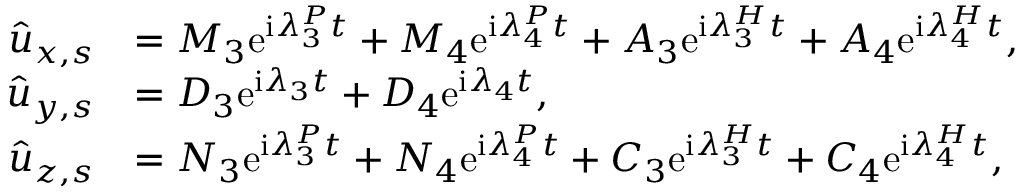<formula> <loc_0><loc_0><loc_500><loc_500>\begin{array} { r l } { \hat { u } _ { x , s } } & { = M _ { 3 } e ^ { i \lambda _ { 3 } ^ { P } t } + M _ { 4 } e ^ { i \lambda _ { 4 } ^ { P } t } + A _ { 3 } e ^ { i { \lambda } _ { 3 } ^ { H } t } + A _ { 4 } e ^ { i { \lambda } _ { 4 } ^ { H } t } , } \\ { \hat { u } _ { y , s } } & { = D _ { 3 } e ^ { i \lambda _ { 3 } t } + D _ { 4 } e ^ { i \lambda _ { 4 } t } , } \\ { \hat { u } _ { z , s } } & { = N _ { 3 } e ^ { i \lambda _ { 3 } ^ { P } t } + N _ { 4 } e ^ { i \lambda _ { 4 } ^ { P } t } + C _ { 3 } e ^ { i { \lambda } _ { 3 } ^ { H } t } + C _ { 4 } e ^ { i { \lambda } _ { 4 } ^ { H } t } , } \end{array}</formula> 